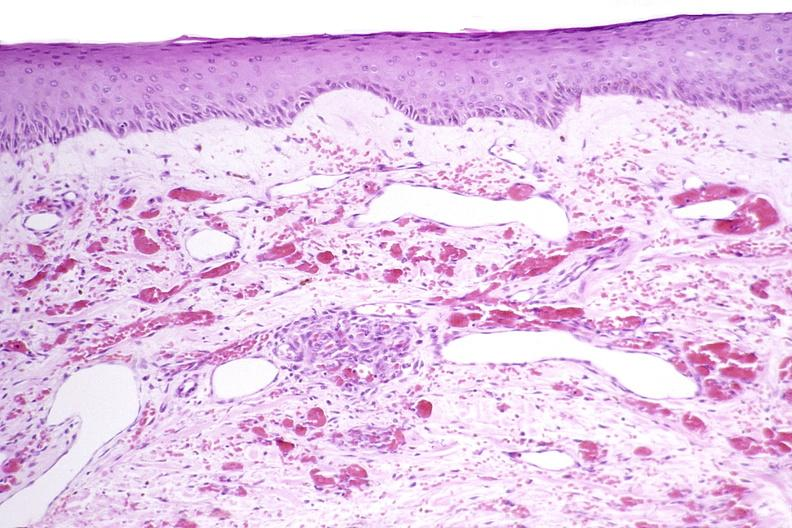where is this?
Answer the question using a single word or phrase. Skin 